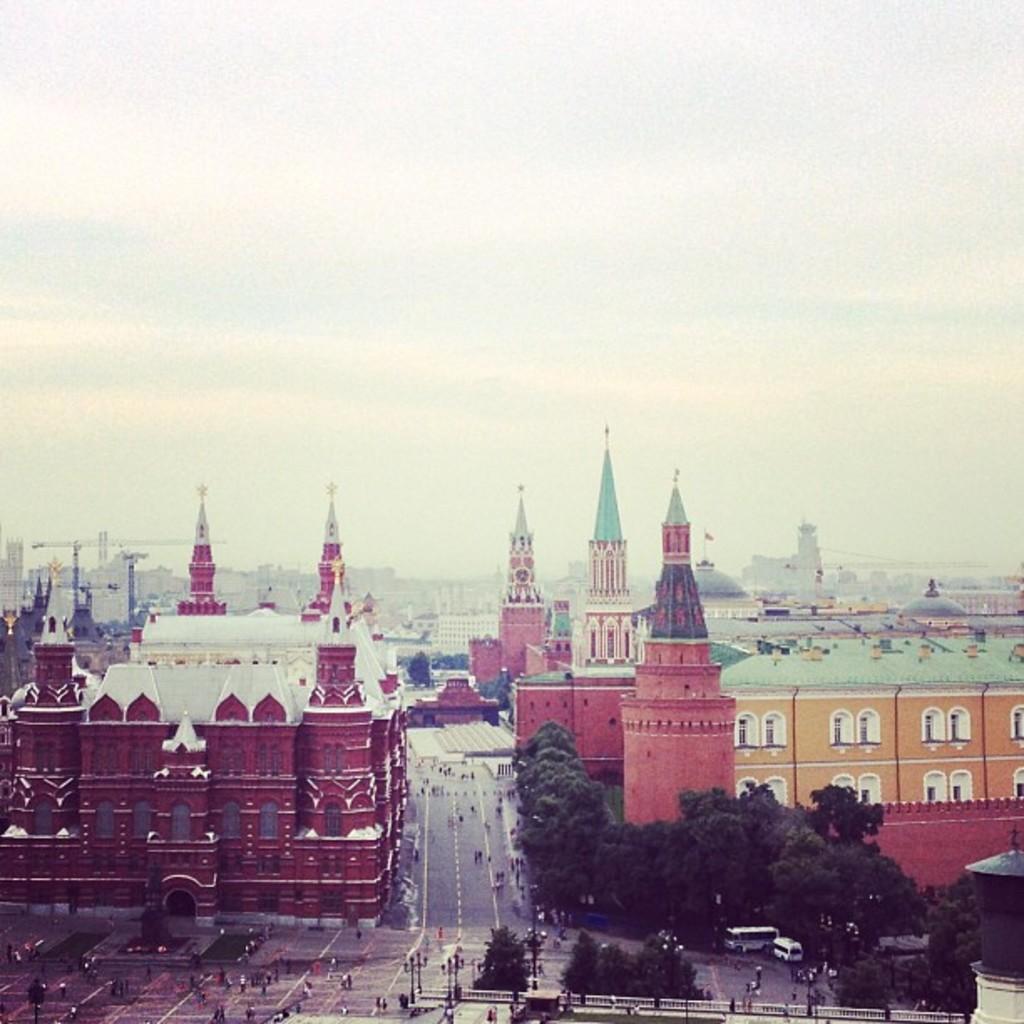Could you give a brief overview of what you see in this image? In this picture we can see buildings with windows, trees, vehicles and some people on the roads and in the background we can see the sky. 